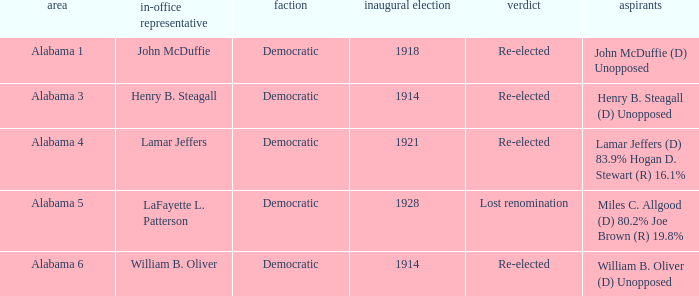Would you mind parsing the complete table? {'header': ['area', 'in-office representative', 'faction', 'inaugural election', 'verdict', 'aspirants'], 'rows': [['Alabama 1', 'John McDuffie', 'Democratic', '1918', 'Re-elected', 'John McDuffie (D) Unopposed'], ['Alabama 3', 'Henry B. Steagall', 'Democratic', '1914', 'Re-elected', 'Henry B. Steagall (D) Unopposed'], ['Alabama 4', 'Lamar Jeffers', 'Democratic', '1921', 'Re-elected', 'Lamar Jeffers (D) 83.9% Hogan D. Stewart (R) 16.1%'], ['Alabama 5', 'LaFayette L. Patterson', 'Democratic', '1928', 'Lost renomination', 'Miles C. Allgood (D) 80.2% Joe Brown (R) 19.8%'], ['Alabama 6', 'William B. Oliver', 'Democratic', '1914', 'Re-elected', 'William B. Oliver (D) Unopposed']]} How many in lost renomination results were elected first? 1928.0. 